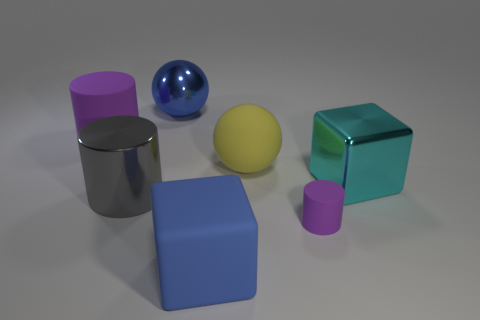What number of purple things are either metal things or matte things?
Ensure brevity in your answer.  2. There is a ball that is made of the same material as the blue cube; what is its color?
Provide a short and direct response. Yellow. How many big things are cylinders or blue spheres?
Keep it short and to the point. 3. Is the number of yellow matte spheres less than the number of small blue metallic things?
Offer a terse response. No. What color is the other large metallic object that is the same shape as the yellow thing?
Provide a succinct answer. Blue. Are there any other things that are the same shape as the big purple matte thing?
Ensure brevity in your answer.  Yes. Is the number of gray matte cubes greater than the number of tiny cylinders?
Offer a terse response. No. What number of other things are made of the same material as the blue sphere?
Ensure brevity in your answer.  2. What is the shape of the purple rubber thing right of the big block that is to the left of the purple cylinder that is to the right of the large blue rubber object?
Ensure brevity in your answer.  Cylinder. Are there fewer blue shiny things that are in front of the big metallic ball than large shiny blocks that are behind the yellow rubber sphere?
Offer a terse response. No. 